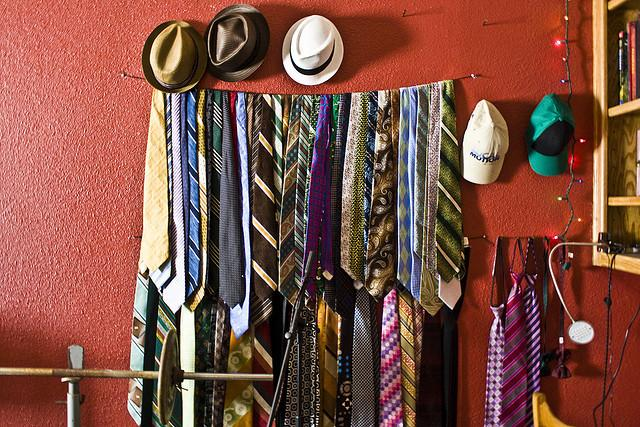Who does this room belong to?

Choices:
A) man
B) girl
C) woman
D) baby man 